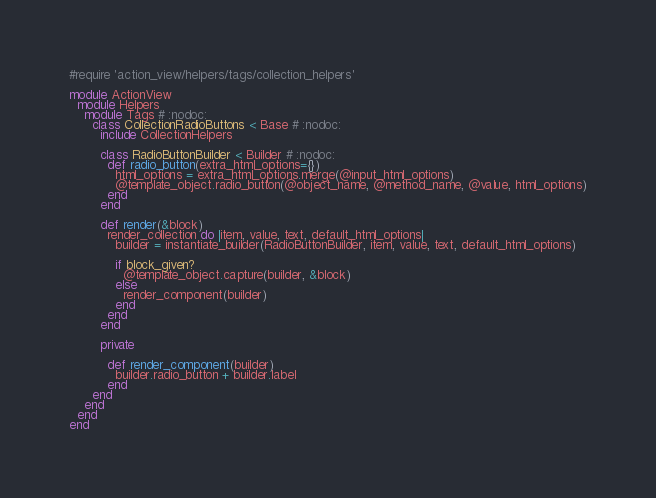Convert code to text. <code><loc_0><loc_0><loc_500><loc_500><_Ruby_>#require 'action_view/helpers/tags/collection_helpers'

module ActionView
  module Helpers
    module Tags # :nodoc:
      class CollectionRadioButtons < Base # :nodoc:
        include CollectionHelpers

        class RadioButtonBuilder < Builder # :nodoc:
          def radio_button(extra_html_options={})
            html_options = extra_html_options.merge(@input_html_options)
            @template_object.radio_button(@object_name, @method_name, @value, html_options)
          end
        end

        def render(&block)
          render_collection do |item, value, text, default_html_options|
            builder = instantiate_builder(RadioButtonBuilder, item, value, text, default_html_options)

            if block_given?
              @template_object.capture(builder, &block)
            else
              render_component(builder)
            end
          end
        end

        private

          def render_component(builder)
            builder.radio_button + builder.label
          end
      end
    end
  end
end
</code> 